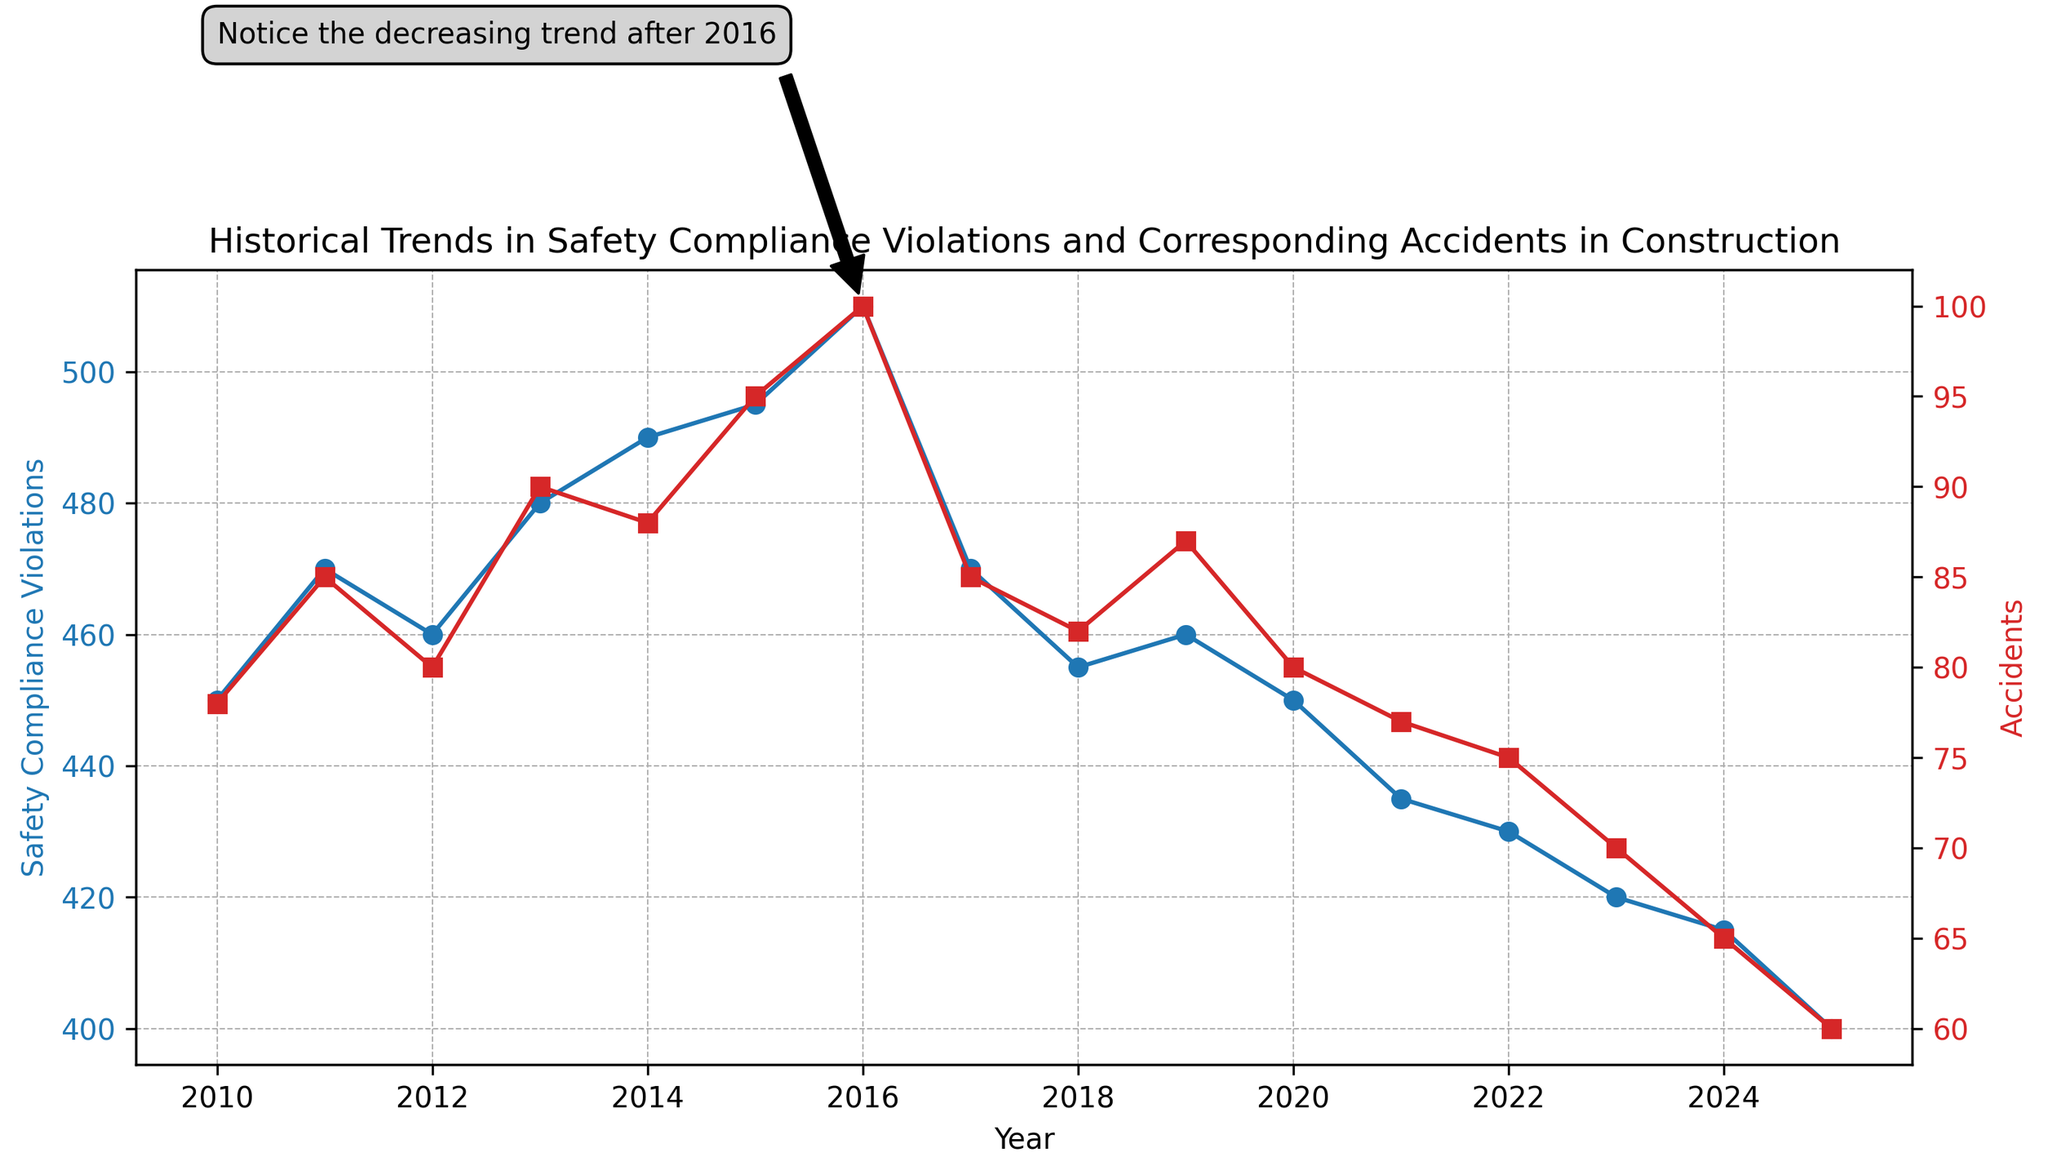What is the trend in safety compliance violations from 2016 to 2025? From the figure, observe the blue line representing safety compliance violations. From 2016 to 2025, the violations decrease steadily.
Answer: Decreasing Between which years did accidents peak? Look at the red line representing accidents. The peak value of 100 occurs in 2016.
Answer: 2016 By how much did safety compliance violations decrease between 2016 and 2025? Violations in 2016 were 510, and in 2025 they were 400. The difference is 510 - 400.
Answer: 110 Which year had the fewest accidents, and how many were recorded? The lowest point on the red line occurs in 2025 with an accident count of 60.
Answer: 2025, 60 What noticeable trend is highlighted by the annotation on the figure? The text annotation points to 2016 and indicates a decreasing trend afterward. This refers to the drop in both safety compliance violations and accidents after 2016.
Answer: Decreasing trend after 2016 Are safety compliance violations and accidents moving in the same or opposite directions over the years? Comparing the blue and red lines, they both follow a similar decreasing trend, especially after 2016. Thus, they are moving in the same direction.
Answer: Same direction What was the difference in accidents between 2015 and 2025? Accidents in 2015 were 95, and in 2025 they were 60. The difference is 95 - 60.
Answer: 35 Did any year have the same number of accidents as the previous year? If so, which year(s)? Check the red line for any horizontal sections; none are present. No two consecutive years have the same number of accidents.
Answer: No How did accidents change from 2011 to 2012? In 2011, there were 85 accidents, and in 2012, there were 80. The number of accidents decreased by 5.
Answer: Decreased by 5 